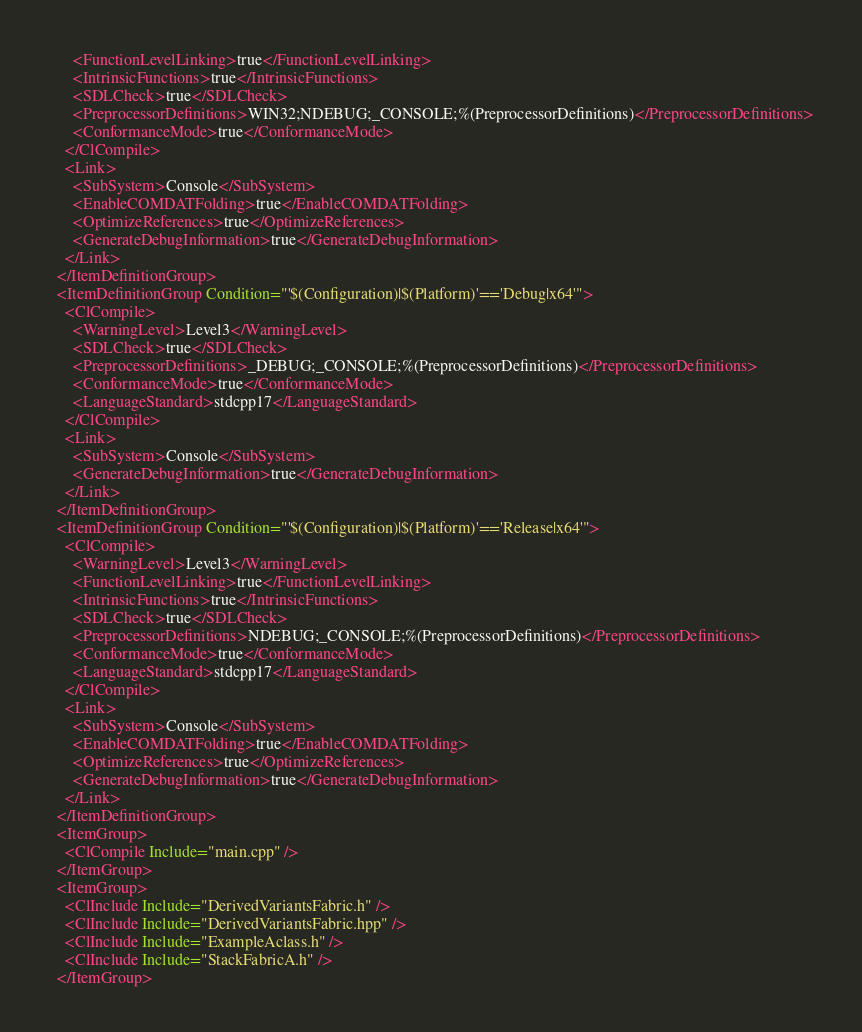<code> <loc_0><loc_0><loc_500><loc_500><_XML_>      <FunctionLevelLinking>true</FunctionLevelLinking>
      <IntrinsicFunctions>true</IntrinsicFunctions>
      <SDLCheck>true</SDLCheck>
      <PreprocessorDefinitions>WIN32;NDEBUG;_CONSOLE;%(PreprocessorDefinitions)</PreprocessorDefinitions>
      <ConformanceMode>true</ConformanceMode>
    </ClCompile>
    <Link>
      <SubSystem>Console</SubSystem>
      <EnableCOMDATFolding>true</EnableCOMDATFolding>
      <OptimizeReferences>true</OptimizeReferences>
      <GenerateDebugInformation>true</GenerateDebugInformation>
    </Link>
  </ItemDefinitionGroup>
  <ItemDefinitionGroup Condition="'$(Configuration)|$(Platform)'=='Debug|x64'">
    <ClCompile>
      <WarningLevel>Level3</WarningLevel>
      <SDLCheck>true</SDLCheck>
      <PreprocessorDefinitions>_DEBUG;_CONSOLE;%(PreprocessorDefinitions)</PreprocessorDefinitions>
      <ConformanceMode>true</ConformanceMode>
      <LanguageStandard>stdcpp17</LanguageStandard>
    </ClCompile>
    <Link>
      <SubSystem>Console</SubSystem>
      <GenerateDebugInformation>true</GenerateDebugInformation>
    </Link>
  </ItemDefinitionGroup>
  <ItemDefinitionGroup Condition="'$(Configuration)|$(Platform)'=='Release|x64'">
    <ClCompile>
      <WarningLevel>Level3</WarningLevel>
      <FunctionLevelLinking>true</FunctionLevelLinking>
      <IntrinsicFunctions>true</IntrinsicFunctions>
      <SDLCheck>true</SDLCheck>
      <PreprocessorDefinitions>NDEBUG;_CONSOLE;%(PreprocessorDefinitions)</PreprocessorDefinitions>
      <ConformanceMode>true</ConformanceMode>
      <LanguageStandard>stdcpp17</LanguageStandard>
    </ClCompile>
    <Link>
      <SubSystem>Console</SubSystem>
      <EnableCOMDATFolding>true</EnableCOMDATFolding>
      <OptimizeReferences>true</OptimizeReferences>
      <GenerateDebugInformation>true</GenerateDebugInformation>
    </Link>
  </ItemDefinitionGroup>
  <ItemGroup>
    <ClCompile Include="main.cpp" />
  </ItemGroup>
  <ItemGroup>
    <ClInclude Include="DerivedVariantsFabric.h" />
    <ClInclude Include="DerivedVariantsFabric.hpp" />
    <ClInclude Include="ExampleAclass.h" />
    <ClInclude Include="StackFabricA.h" />
  </ItemGroup></code> 